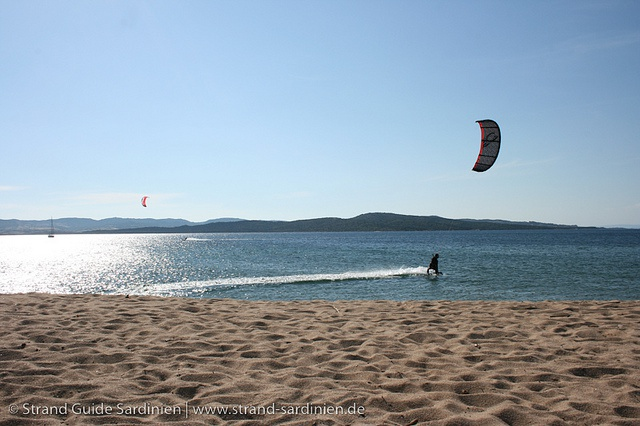Describe the objects in this image and their specific colors. I can see kite in lightblue, black, and purple tones, people in lightblue, black, gray, and darkblue tones, kite in lightblue, lightgray, salmon, darkgray, and lightpink tones, and boat in gray, black, brown, and lightblue tones in this image. 